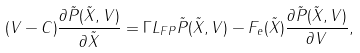<formula> <loc_0><loc_0><loc_500><loc_500>( V - C ) \frac { \partial \tilde { P } ( \tilde { X } , V ) } { \partial \tilde { X } } = \Gamma L _ { F P } \tilde { P } ( \tilde { X } , V ) - F _ { e } ( \tilde { X } ) \frac { \partial \tilde { P } ( \tilde { X } , V ) } { \partial V } ,</formula> 